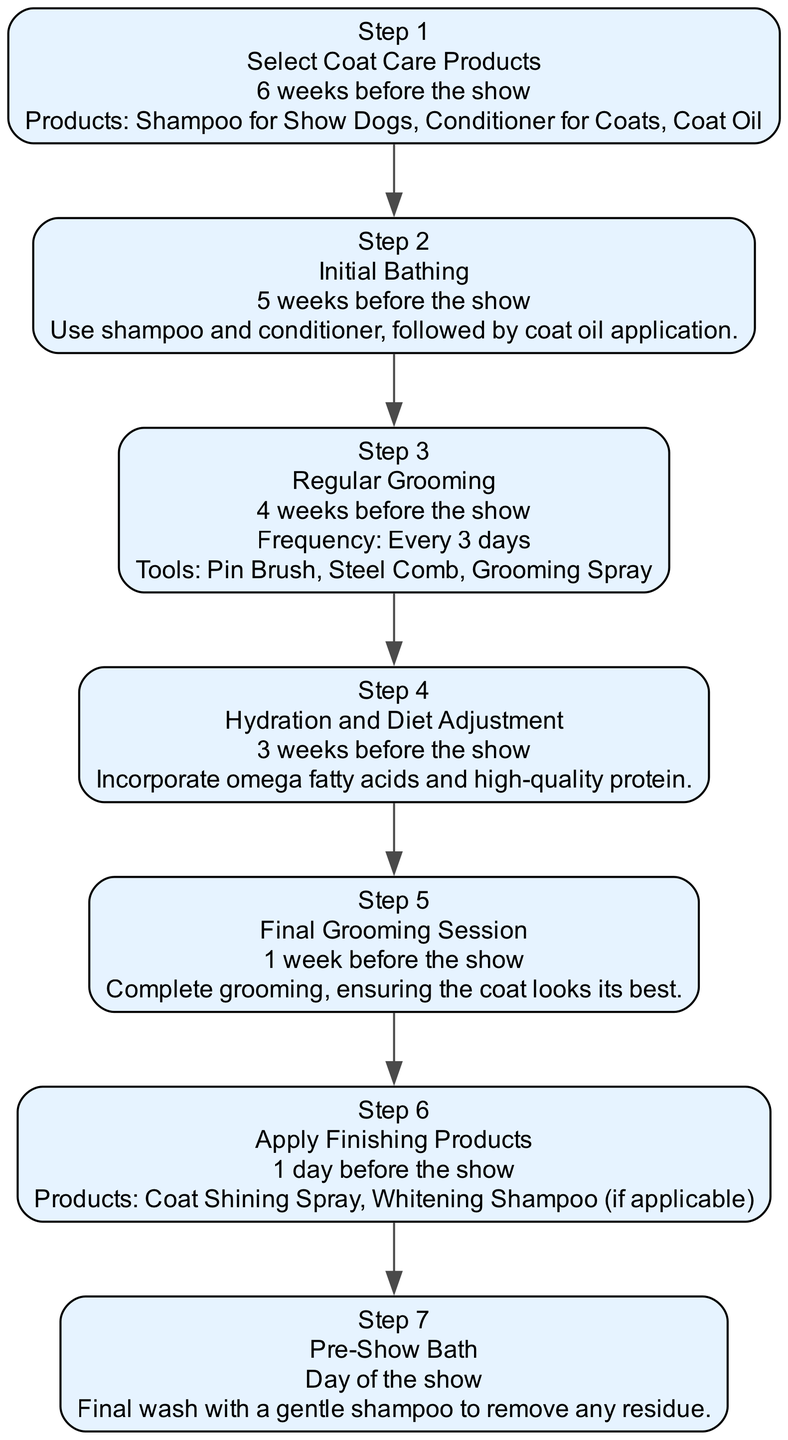What is the first action in the timeline? The first action is found in Step 1, where it states "Select Coat Care Products." This step is listed first in the diagram and outlines the initial activity leading up to the dog show.
Answer: Select Coat Care Products How many products are selected in Step 1? In Step 1, three products are listed: Shampoo for Show Dogs, Conditioner for Coats, and Coat Oil. Counting these products gives the total.
Answer: 3 What is the duration for the "Final Grooming Session"? The duration for the "Final Grooming Session" is specified as "1 week before the show." This detail is provided alongside the action description in Step 5 of the diagram.
Answer: 1 week before the show What tools are used during the "Regular Grooming"? In Step 3, the tools listed for "Regular Grooming" include a Pin Brush, Steel Comb, and Grooming Spray. These tools are specifically mentioned under the details of that step in the diagram.
Answer: Pin Brush, Steel Comb, Grooming Spray Which action happens right before the "Pre-Show Bath"? The "Apply Finishing Products" action occurs right before the "Pre-Show Bath." This can be determined by following the directed edges in the diagram, which connect these two steps in sequential order.
Answer: Apply Finishing Products How frequently should regular grooming occur? Regular grooming is to take place every 3 days as indicated in Step 3 of the timeline. This frequency is explicitly outlined in the details of that step.
Answer: Every 3 days What products are applied on the day before the show? On the day before the show in Step 6, the products listed for application are Coat Shining Spray and Whitening Shampoo (if applicable). This information is clearly stated in the details of that step.
Answer: Coat Shining Spray, Whitening Shampoo (if applicable) Which step includes diet adjustments? "Hydration and Diet Adjustment" is the step that includes dietary changes, as outlined in Step 4. The details specify incorporating omega fatty acids and high-quality protein to aid coat condition.
Answer: Hydration and Diet Adjustment How many total steps are there in the timeline? The timeline lists a total of 7 steps from the initial product selection to the final bathing on the day of the show. Counting each step sequentially provides this total.
Answer: 7 